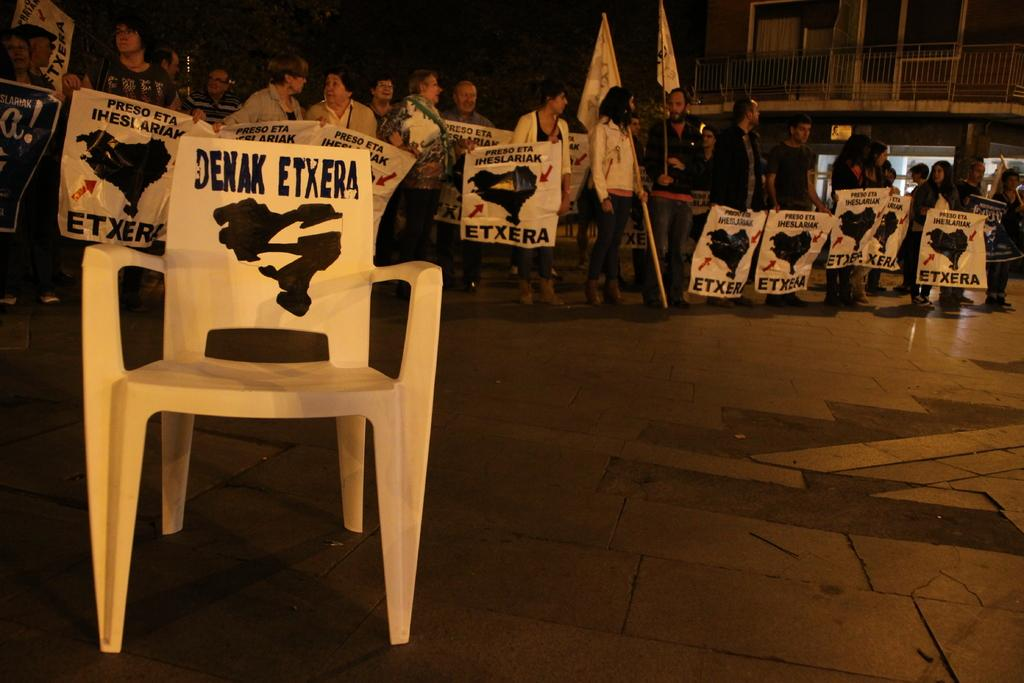What object is located on the left side of the image? There is a chair on the left side of the image. What are the people behind the chair doing? The people are holding banners. What can be seen in the image besides the chair and people? There are flags and buildings visible in the image. Can you tell me how many mice are sitting on the chair in the image? There are no mice present in the image; the chair is empty. What type of arch can be seen in the image? There is no arch visible in the image. 